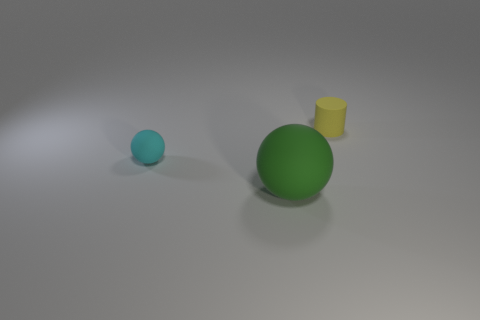What number of other things are the same color as the small cylinder? 0 